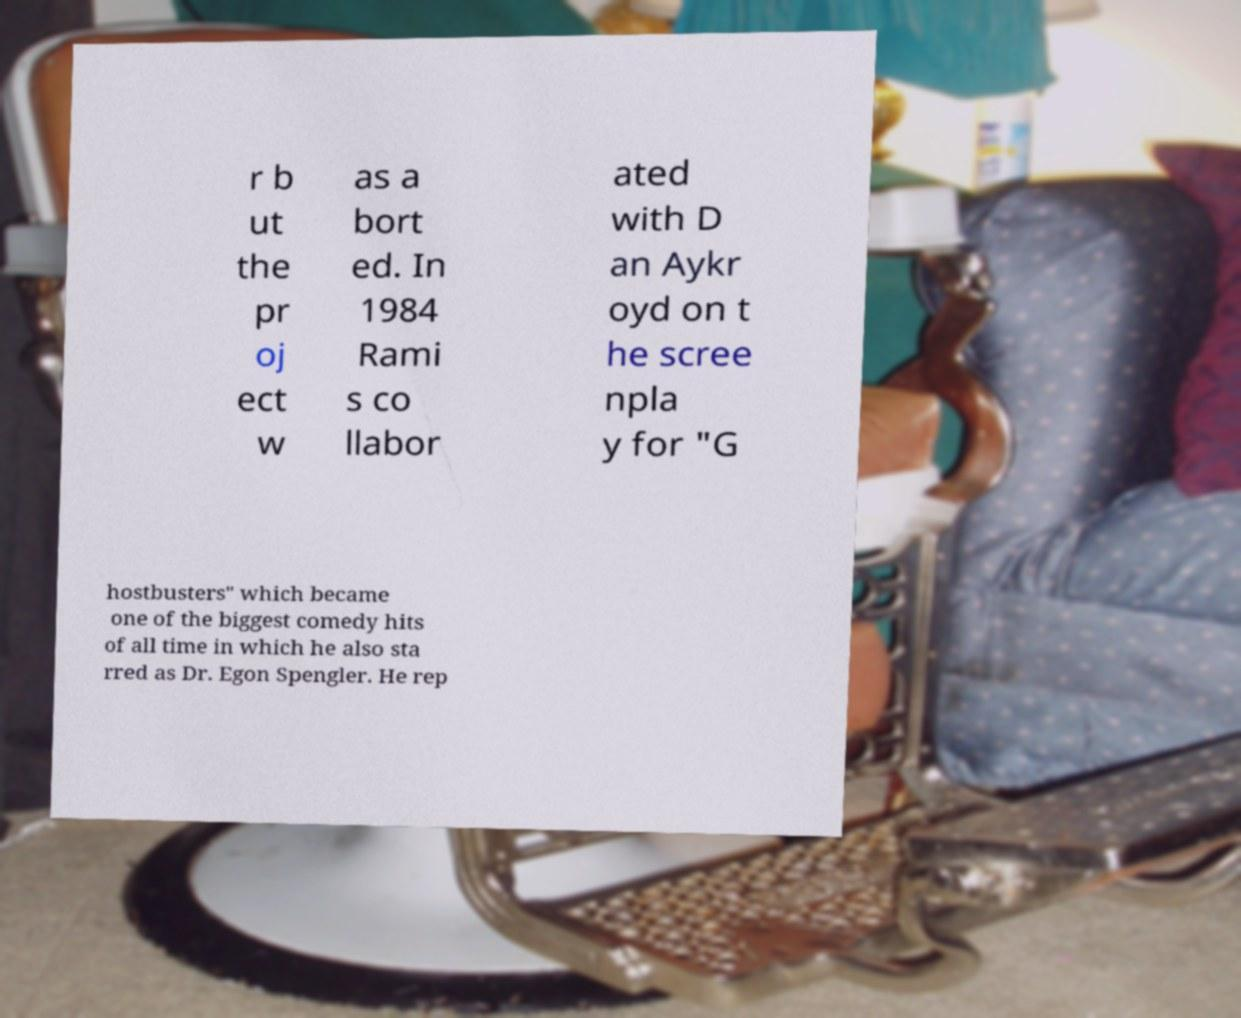What messages or text are displayed in this image? I need them in a readable, typed format. r b ut the pr oj ect w as a bort ed. In 1984 Rami s co llabor ated with D an Aykr oyd on t he scree npla y for "G hostbusters" which became one of the biggest comedy hits of all time in which he also sta rred as Dr. Egon Spengler. He rep 